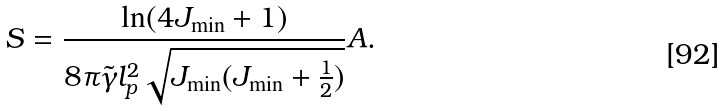<formula> <loc_0><loc_0><loc_500><loc_500>S = \frac { \ln ( 4 J _ { \min } + 1 ) } { 8 \pi \tilde { \gamma } l _ { p } ^ { 2 } \sqrt { J _ { \min } ( J _ { \min } + \frac { 1 } { 2 } ) } } A .</formula> 